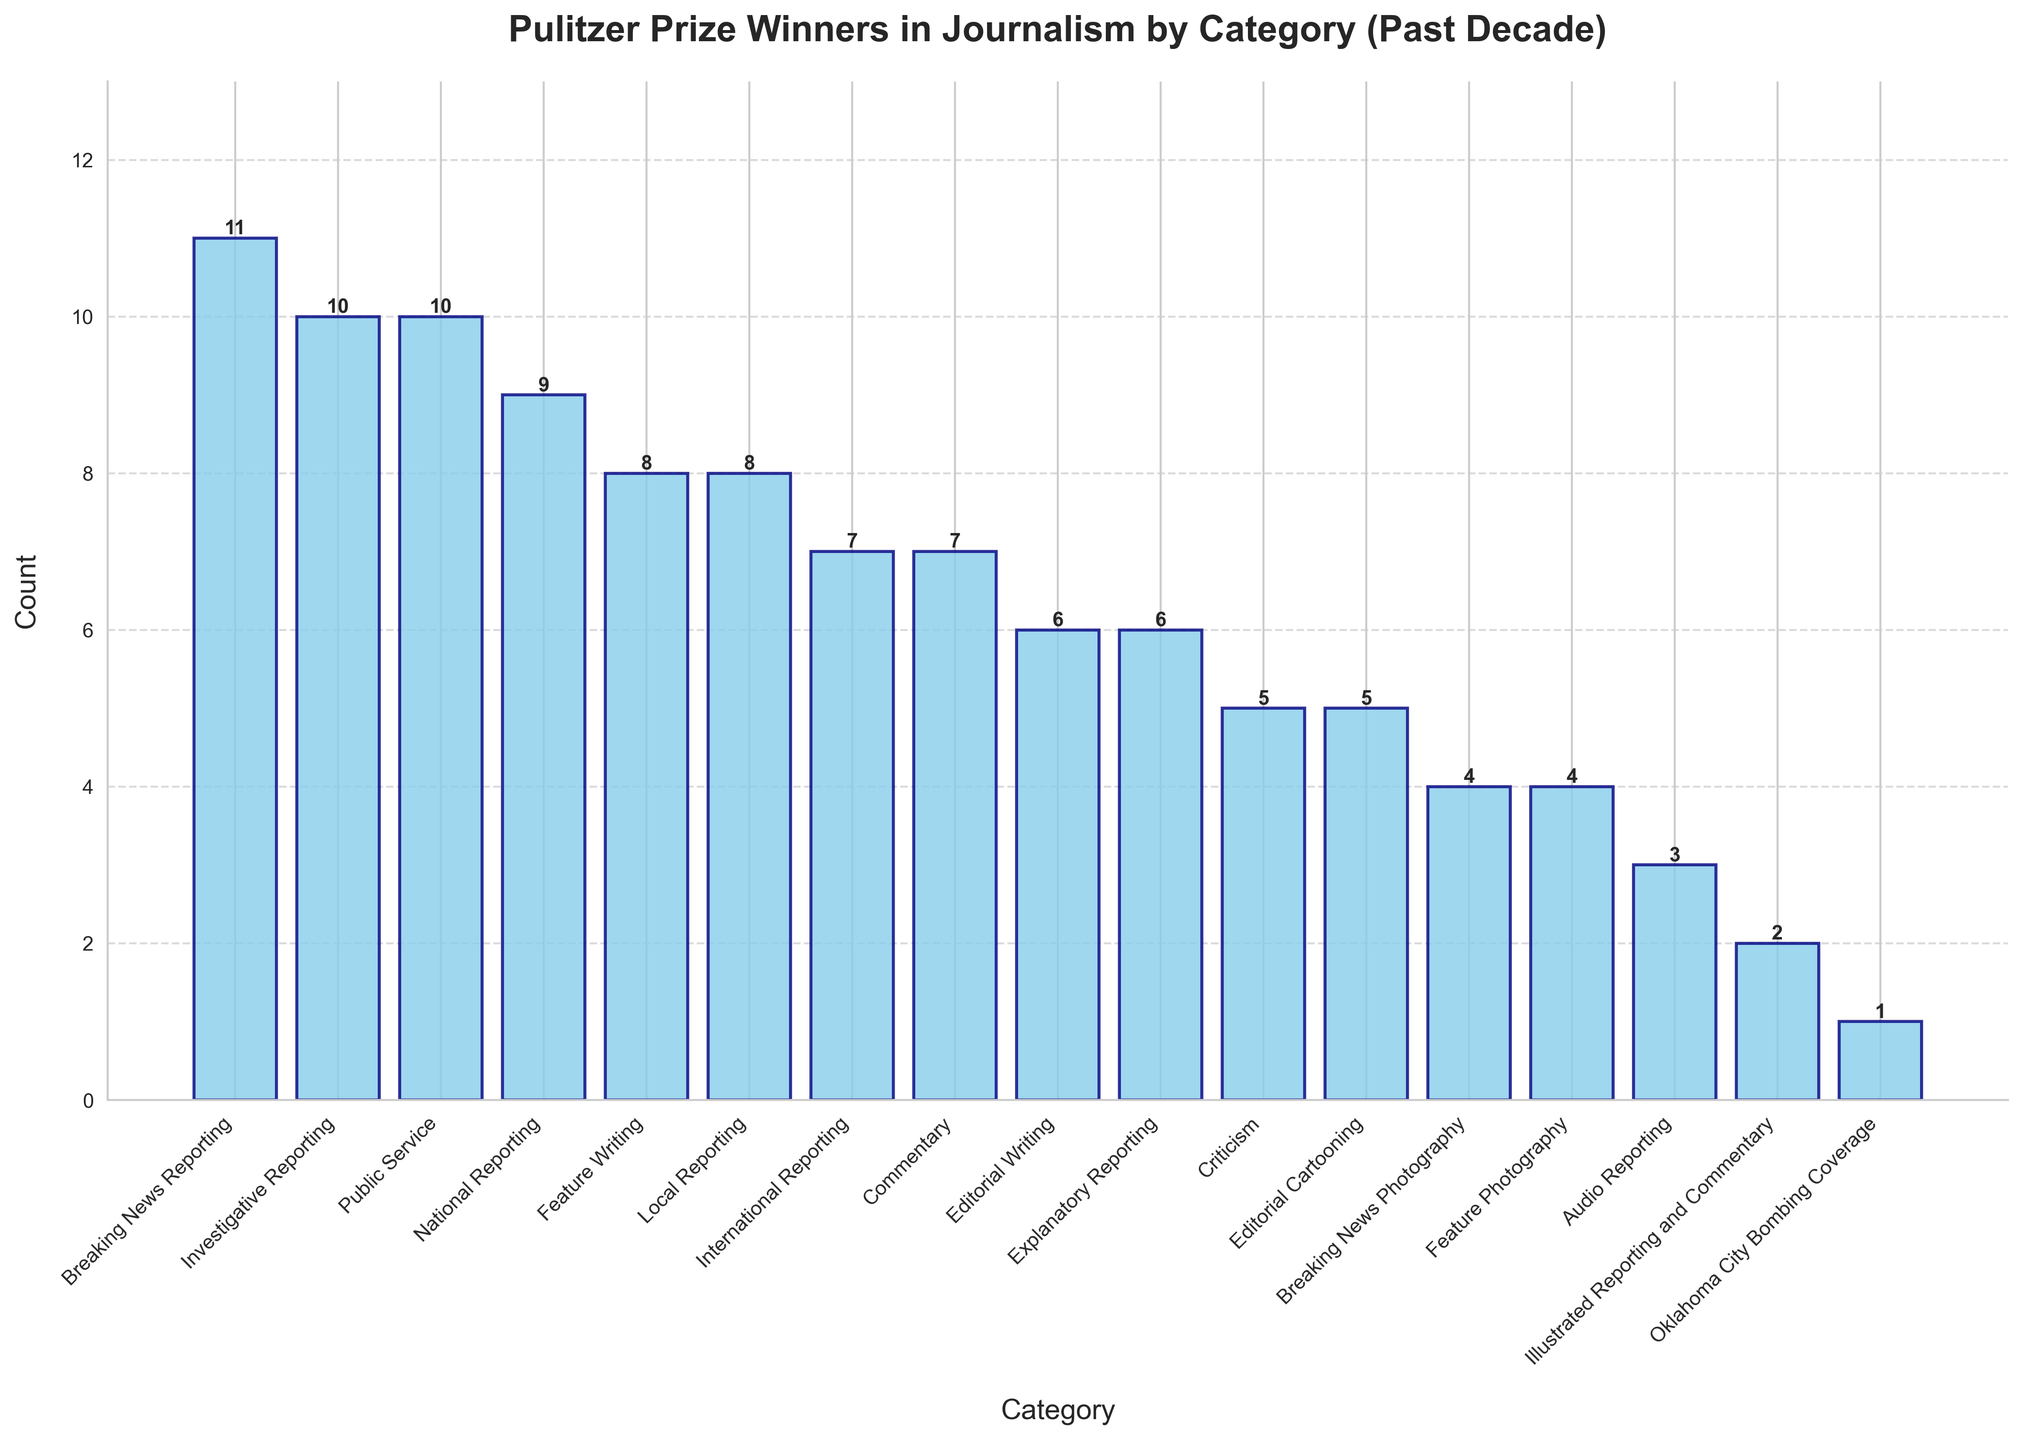How many categories have more than 7 Pulitzer Prize winners? First, look at the heights of all the bars. Then, count the number of bars that have a height greater than 7.
Answer: 8 Which category has the highest number of Pulitzer Prize winners? Locate the tallest bar on the chart and check the corresponding category label.
Answer: Breaking News Reporting Compare Breaking News Reporting and Investigative Reporting—how many more Pulitzer Prize winners does Breaking News Reporting have? Note the counts for both categories: Breaking News Reporting has 11 and Investigative Reporting has 10. Subtract the latter from the former.
Answer: 1 What is the total number of Pulitzer Prize winners across all categories? Add up the counts for all categories: 11 + 10 + 10 + 9 + 8 + 8 + 7 + 7 + 6 + 6 + 5 + 5 + 4 + 4 + 3 + 2 + 1 = 96.
Answer: 96 How many categories have fewer than 5 Pulitzer Prize winners? Identify the bars with a height less than 5, then count them.
Answer: 4 Which category has the lowest number of Pulitzer Prize winners, and how many does it have? Identify the shortest bar and check its label and height.
Answer: Oklahoma City Bombing Coverage, 1 What is the combined total of Pulitzer Prize winners in the categories of National Reporting and International Reporting? Add the counts for both categories: National Reporting has 9 and International Reporting has 7. Therefore, 9 + 7 = 16.
Answer: 16 Are there more winners in Commentary or Editorial Writing? Compare the heights of the bars for Commentary and Editorial Writing. Commentary has 7, and Editorial Writing has 6.
Answer: Commentary What's the average number of Pulitzer Prize winners per category? Calculate the total number of winners (96) and divide by the number of categories (16): 96/16 = 6.
Answer: 6 What is the sum of winners in the categories with exactly 4 Pulitzer Prize winners? Identify the categories with 4 winners: Breaking News Photography and Feature Photography. Sum their counts: 4 + 4 = 8.
Answer: 8 